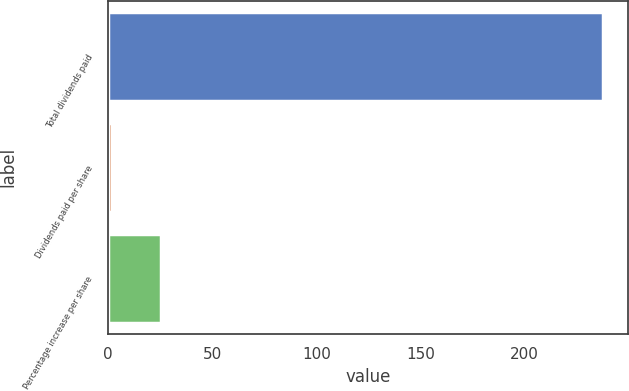<chart> <loc_0><loc_0><loc_500><loc_500><bar_chart><fcel>Total dividends paid<fcel>Dividends paid per share<fcel>Percentage increase per share<nl><fcel>237.6<fcel>1.88<fcel>25.45<nl></chart> 